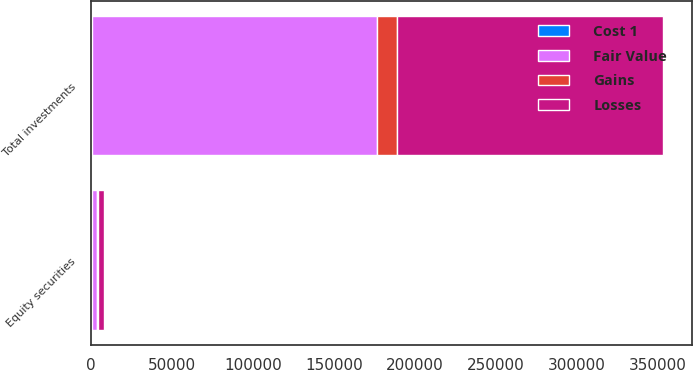<chart> <loc_0><loc_0><loc_500><loc_500><stacked_bar_chart><ecel><fcel>Equity securities<fcel>Total investments<nl><fcel>Losses<fcel>3685<fcel>164515<nl><fcel>Fair Value<fcel>3521<fcel>176320<nl><fcel>Gains<fcel>236<fcel>12205<nl><fcel>Cost 1<fcel>400<fcel>400<nl></chart> 